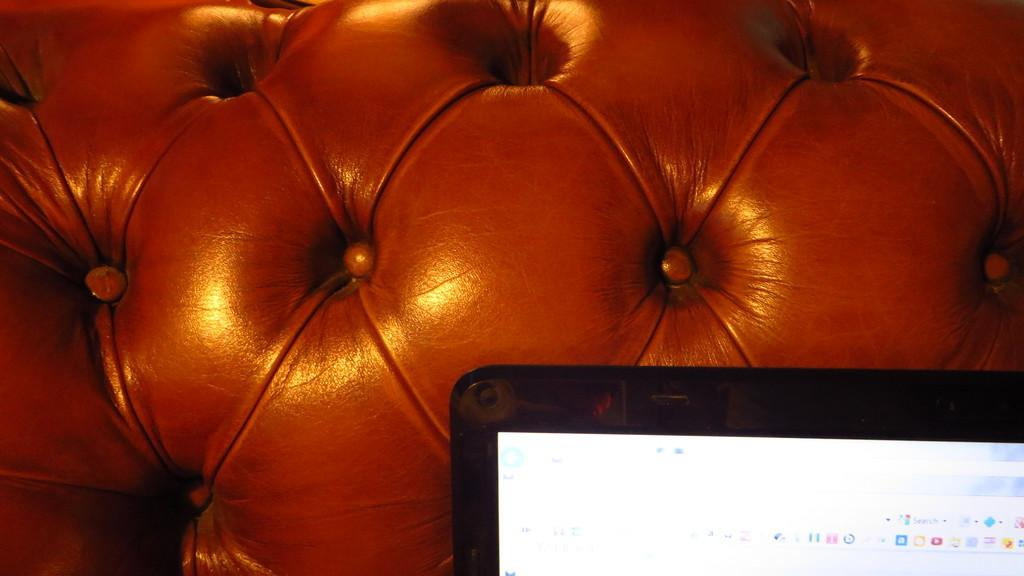What electronic device is visible on the right side of the image? There is a laptop screen on the right side of the image. What type of furniture can be seen in the background of the image? There is a couch in the background of the image. What type of flag is being waved by the person on the couch in the image? There is no person or flag visible in the image; it only features a laptop screen and a couch in the background. 